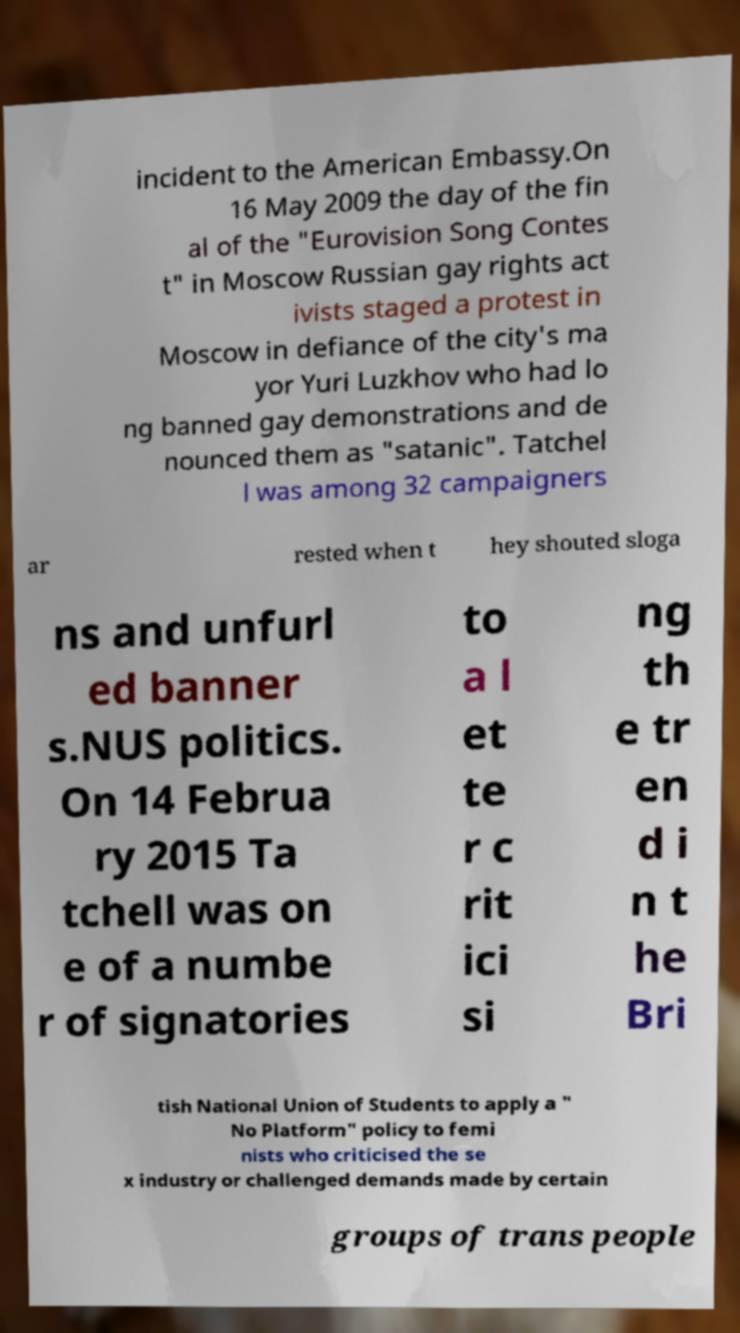Could you assist in decoding the text presented in this image and type it out clearly? incident to the American Embassy.On 16 May 2009 the day of the fin al of the "Eurovision Song Contes t" in Moscow Russian gay rights act ivists staged a protest in Moscow in defiance of the city's ma yor Yuri Luzkhov who had lo ng banned gay demonstrations and de nounced them as "satanic". Tatchel l was among 32 campaigners ar rested when t hey shouted sloga ns and unfurl ed banner s.NUS politics. On 14 Februa ry 2015 Ta tchell was on e of a numbe r of signatories to a l et te r c rit ici si ng th e tr en d i n t he Bri tish National Union of Students to apply a " No Platform" policy to femi nists who criticised the se x industry or challenged demands made by certain groups of trans people 